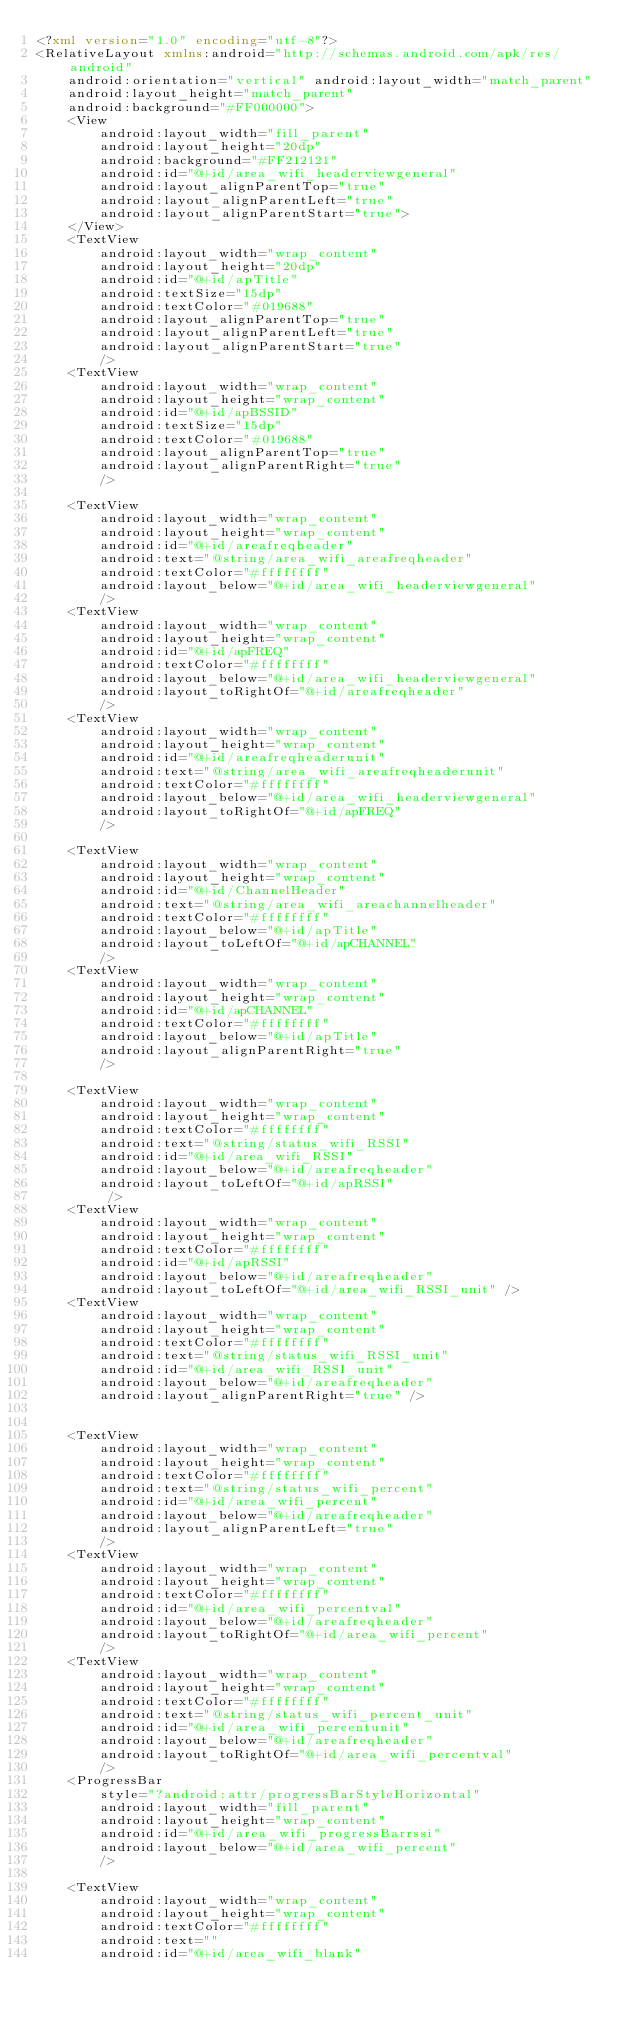Convert code to text. <code><loc_0><loc_0><loc_500><loc_500><_XML_><?xml version="1.0" encoding="utf-8"?>
<RelativeLayout xmlns:android="http://schemas.android.com/apk/res/android"
    android:orientation="vertical" android:layout_width="match_parent"
    android:layout_height="match_parent"
    android:background="#FF000000">
    <View
        android:layout_width="fill_parent"
        android:layout_height="20dp"
        android:background="#FF212121"
        android:id="@+id/area_wifi_headerviewgeneral"
        android:layout_alignParentTop="true"
        android:layout_alignParentLeft="true"
        android:layout_alignParentStart="true">
    </View>
    <TextView
        android:layout_width="wrap_content"
        android:layout_height="20dp"
        android:id="@+id/apTitle"
        android:textSize="15dp"
        android:textColor="#019688"
        android:layout_alignParentTop="true"
        android:layout_alignParentLeft="true"
        android:layout_alignParentStart="true"
        />
    <TextView
        android:layout_width="wrap_content"
        android:layout_height="wrap_content"
        android:id="@+id/apBSSID"
        android:textSize="15dp"
        android:textColor="#019688"
        android:layout_alignParentTop="true"
        android:layout_alignParentRight="true"
        />

    <TextView
        android:layout_width="wrap_content"
        android:layout_height="wrap_content"
        android:id="@+id/areafreqheader"
        android:text="@string/area_wifi_areafreqheader"
        android:textColor="#ffffffff"
        android:layout_below="@+id/area_wifi_headerviewgeneral"
        />
    <TextView
        android:layout_width="wrap_content"
        android:layout_height="wrap_content"
        android:id="@+id/apFREQ"
        android:textColor="#ffffffff"
        android:layout_below="@+id/area_wifi_headerviewgeneral"
        android:layout_toRightOf="@+id/areafreqheader"
        />
    <TextView
        android:layout_width="wrap_content"
        android:layout_height="wrap_content"
        android:id="@+id/areafreqheaderunit"
        android:text="@string/area_wifi_areafreqheaderunit"
        android:textColor="#ffffffff"
        android:layout_below="@+id/area_wifi_headerviewgeneral"
        android:layout_toRightOf="@+id/apFREQ"
        />

    <TextView
        android:layout_width="wrap_content"
        android:layout_height="wrap_content"
        android:id="@+id/ChannelHeader"
        android:text="@string/area_wifi_areachannelheader"
        android:textColor="#ffffffff"
        android:layout_below="@+id/apTitle"
        android:layout_toLeftOf="@+id/apCHANNEL"
        />
    <TextView
        android:layout_width="wrap_content"
        android:layout_height="wrap_content"
        android:id="@+id/apCHANNEL"
        android:textColor="#ffffffff"
        android:layout_below="@+id/apTitle"
        android:layout_alignParentRight="true"
        />

    <TextView
        android:layout_width="wrap_content"
        android:layout_height="wrap_content"
        android:textColor="#ffffffff"
        android:text="@string/status_wifi_RSSI"
        android:id="@+id/area_wifi_RSSI"
        android:layout_below="@+id/areafreqheader"
        android:layout_toLeftOf="@+id/apRSSI"
         />
    <TextView
        android:layout_width="wrap_content"
        android:layout_height="wrap_content"
        android:textColor="#ffffffff"
        android:id="@+id/apRSSI"
        android:layout_below="@+id/areafreqheader"
        android:layout_toLeftOf="@+id/area_wifi_RSSI_unit" />
    <TextView
        android:layout_width="wrap_content"
        android:layout_height="wrap_content"
        android:textColor="#ffffffff"
        android:text="@string/status_wifi_RSSI_unit"
        android:id="@+id/area_wifi_RSSI_unit"
        android:layout_below="@+id/areafreqheader"
        android:layout_alignParentRight="true" />


    <TextView
        android:layout_width="wrap_content"
        android:layout_height="wrap_content"
        android:textColor="#ffffffff"
        android:text="@string/status_wifi_percent"
        android:id="@+id/area_wifi_percent"
        android:layout_below="@+id/areafreqheader"
        android:layout_alignParentLeft="true"
        />
    <TextView
        android:layout_width="wrap_content"
        android:layout_height="wrap_content"
        android:textColor="#ffffffff"
        android:id="@+id/area_wifi_percentval"
        android:layout_below="@+id/areafreqheader"
        android:layout_toRightOf="@+id/area_wifi_percent"
        />
    <TextView
        android:layout_width="wrap_content"
        android:layout_height="wrap_content"
        android:textColor="#ffffffff"
        android:text="@string/status_wifi_percent_unit"
        android:id="@+id/area_wifi_percentunit"
        android:layout_below="@+id/areafreqheader"
        android:layout_toRightOf="@+id/area_wifi_percentval"
        />
    <ProgressBar
        style="?android:attr/progressBarStyleHorizontal"
        android:layout_width="fill_parent"
        android:layout_height="wrap_content"
        android:id="@+id/area_wifi_progressBarrssi"
        android:layout_below="@+id/area_wifi_percent"
        />

    <TextView
        android:layout_width="wrap_content"
        android:layout_height="wrap_content"
        android:textColor="#ffffffff"
        android:text=""
        android:id="@+id/area_wifi_blank"</code> 